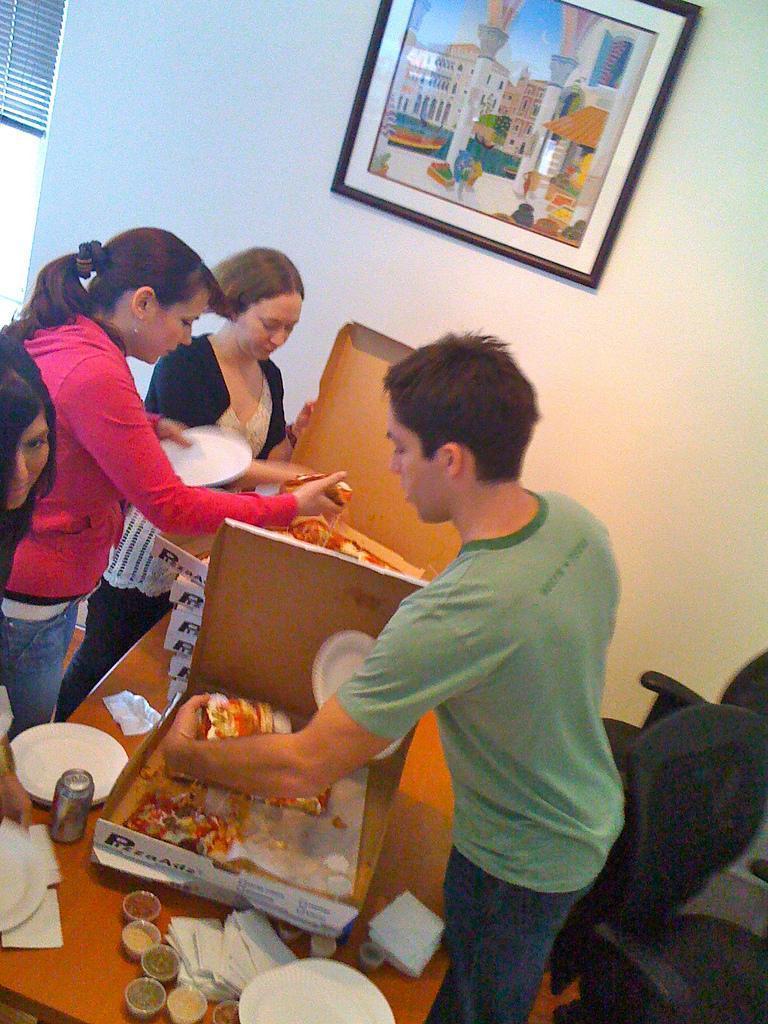How many boys take the pizza in the image?
Give a very brief answer. 1. 